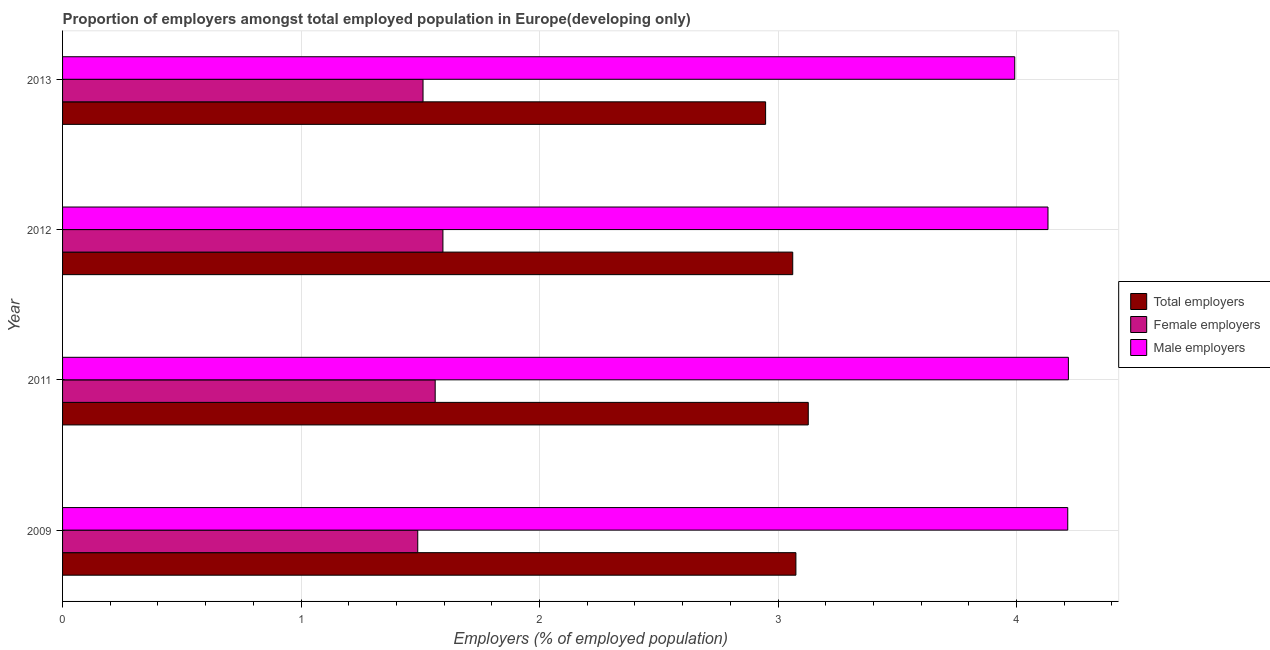How many different coloured bars are there?
Provide a succinct answer. 3. How many bars are there on the 1st tick from the bottom?
Your response must be concise. 3. What is the percentage of total employers in 2009?
Provide a succinct answer. 3.07. Across all years, what is the maximum percentage of female employers?
Offer a very short reply. 1.59. Across all years, what is the minimum percentage of female employers?
Keep it short and to the point. 1.49. In which year was the percentage of female employers minimum?
Your answer should be compact. 2009. What is the total percentage of total employers in the graph?
Make the answer very short. 12.21. What is the difference between the percentage of male employers in 2011 and that in 2012?
Provide a short and direct response. 0.09. What is the difference between the percentage of total employers in 2011 and the percentage of male employers in 2009?
Offer a very short reply. -1.09. What is the average percentage of female employers per year?
Make the answer very short. 1.54. In the year 2009, what is the difference between the percentage of total employers and percentage of male employers?
Keep it short and to the point. -1.14. What is the ratio of the percentage of male employers in 2012 to that in 2013?
Offer a very short reply. 1.03. Is the percentage of total employers in 2009 less than that in 2011?
Your answer should be very brief. Yes. What is the difference between the highest and the second highest percentage of female employers?
Provide a short and direct response. 0.03. What is the difference between the highest and the lowest percentage of female employers?
Offer a very short reply. 0.11. What does the 3rd bar from the top in 2011 represents?
Your response must be concise. Total employers. What does the 1st bar from the bottom in 2013 represents?
Make the answer very short. Total employers. Are all the bars in the graph horizontal?
Your answer should be very brief. Yes. Are the values on the major ticks of X-axis written in scientific E-notation?
Your response must be concise. No. How are the legend labels stacked?
Give a very brief answer. Vertical. What is the title of the graph?
Your answer should be compact. Proportion of employers amongst total employed population in Europe(developing only). What is the label or title of the X-axis?
Your answer should be very brief. Employers (% of employed population). What is the Employers (% of employed population) of Total employers in 2009?
Your answer should be very brief. 3.07. What is the Employers (% of employed population) in Female employers in 2009?
Give a very brief answer. 1.49. What is the Employers (% of employed population) of Male employers in 2009?
Your answer should be compact. 4.21. What is the Employers (% of employed population) in Total employers in 2011?
Provide a short and direct response. 3.13. What is the Employers (% of employed population) in Female employers in 2011?
Make the answer very short. 1.56. What is the Employers (% of employed population) in Male employers in 2011?
Offer a terse response. 4.22. What is the Employers (% of employed population) of Total employers in 2012?
Provide a succinct answer. 3.06. What is the Employers (% of employed population) of Female employers in 2012?
Ensure brevity in your answer.  1.59. What is the Employers (% of employed population) in Male employers in 2012?
Keep it short and to the point. 4.13. What is the Employers (% of employed population) of Total employers in 2013?
Your answer should be very brief. 2.95. What is the Employers (% of employed population) of Female employers in 2013?
Your answer should be compact. 1.51. What is the Employers (% of employed population) in Male employers in 2013?
Provide a succinct answer. 3.99. Across all years, what is the maximum Employers (% of employed population) of Total employers?
Give a very brief answer. 3.13. Across all years, what is the maximum Employers (% of employed population) of Female employers?
Your answer should be very brief. 1.59. Across all years, what is the maximum Employers (% of employed population) of Male employers?
Make the answer very short. 4.22. Across all years, what is the minimum Employers (% of employed population) of Total employers?
Make the answer very short. 2.95. Across all years, what is the minimum Employers (% of employed population) in Female employers?
Give a very brief answer. 1.49. Across all years, what is the minimum Employers (% of employed population) in Male employers?
Ensure brevity in your answer.  3.99. What is the total Employers (% of employed population) of Total employers in the graph?
Keep it short and to the point. 12.21. What is the total Employers (% of employed population) in Female employers in the graph?
Ensure brevity in your answer.  6.16. What is the total Employers (% of employed population) of Male employers in the graph?
Give a very brief answer. 16.56. What is the difference between the Employers (% of employed population) in Total employers in 2009 and that in 2011?
Your answer should be very brief. -0.05. What is the difference between the Employers (% of employed population) of Female employers in 2009 and that in 2011?
Keep it short and to the point. -0.07. What is the difference between the Employers (% of employed population) in Male employers in 2009 and that in 2011?
Provide a short and direct response. -0. What is the difference between the Employers (% of employed population) of Total employers in 2009 and that in 2012?
Offer a terse response. 0.01. What is the difference between the Employers (% of employed population) in Female employers in 2009 and that in 2012?
Offer a terse response. -0.11. What is the difference between the Employers (% of employed population) in Male employers in 2009 and that in 2012?
Give a very brief answer. 0.08. What is the difference between the Employers (% of employed population) in Total employers in 2009 and that in 2013?
Offer a terse response. 0.13. What is the difference between the Employers (% of employed population) in Female employers in 2009 and that in 2013?
Ensure brevity in your answer.  -0.02. What is the difference between the Employers (% of employed population) of Male employers in 2009 and that in 2013?
Your response must be concise. 0.22. What is the difference between the Employers (% of employed population) in Total employers in 2011 and that in 2012?
Offer a terse response. 0.07. What is the difference between the Employers (% of employed population) in Female employers in 2011 and that in 2012?
Your answer should be compact. -0.03. What is the difference between the Employers (% of employed population) in Male employers in 2011 and that in 2012?
Your answer should be very brief. 0.09. What is the difference between the Employers (% of employed population) of Total employers in 2011 and that in 2013?
Keep it short and to the point. 0.18. What is the difference between the Employers (% of employed population) of Female employers in 2011 and that in 2013?
Ensure brevity in your answer.  0.05. What is the difference between the Employers (% of employed population) of Male employers in 2011 and that in 2013?
Your response must be concise. 0.23. What is the difference between the Employers (% of employed population) in Total employers in 2012 and that in 2013?
Offer a very short reply. 0.11. What is the difference between the Employers (% of employed population) of Female employers in 2012 and that in 2013?
Your response must be concise. 0.08. What is the difference between the Employers (% of employed population) in Male employers in 2012 and that in 2013?
Make the answer very short. 0.14. What is the difference between the Employers (% of employed population) of Total employers in 2009 and the Employers (% of employed population) of Female employers in 2011?
Your answer should be compact. 1.51. What is the difference between the Employers (% of employed population) of Total employers in 2009 and the Employers (% of employed population) of Male employers in 2011?
Keep it short and to the point. -1.14. What is the difference between the Employers (% of employed population) of Female employers in 2009 and the Employers (% of employed population) of Male employers in 2011?
Your answer should be compact. -2.73. What is the difference between the Employers (% of employed population) in Total employers in 2009 and the Employers (% of employed population) in Female employers in 2012?
Offer a very short reply. 1.48. What is the difference between the Employers (% of employed population) of Total employers in 2009 and the Employers (% of employed population) of Male employers in 2012?
Provide a short and direct response. -1.06. What is the difference between the Employers (% of employed population) in Female employers in 2009 and the Employers (% of employed population) in Male employers in 2012?
Ensure brevity in your answer.  -2.64. What is the difference between the Employers (% of employed population) of Total employers in 2009 and the Employers (% of employed population) of Female employers in 2013?
Ensure brevity in your answer.  1.56. What is the difference between the Employers (% of employed population) in Total employers in 2009 and the Employers (% of employed population) in Male employers in 2013?
Your answer should be compact. -0.92. What is the difference between the Employers (% of employed population) of Female employers in 2009 and the Employers (% of employed population) of Male employers in 2013?
Your response must be concise. -2.5. What is the difference between the Employers (% of employed population) in Total employers in 2011 and the Employers (% of employed population) in Female employers in 2012?
Your answer should be very brief. 1.53. What is the difference between the Employers (% of employed population) in Total employers in 2011 and the Employers (% of employed population) in Male employers in 2012?
Make the answer very short. -1.01. What is the difference between the Employers (% of employed population) in Female employers in 2011 and the Employers (% of employed population) in Male employers in 2012?
Keep it short and to the point. -2.57. What is the difference between the Employers (% of employed population) of Total employers in 2011 and the Employers (% of employed population) of Female employers in 2013?
Offer a terse response. 1.62. What is the difference between the Employers (% of employed population) in Total employers in 2011 and the Employers (% of employed population) in Male employers in 2013?
Ensure brevity in your answer.  -0.87. What is the difference between the Employers (% of employed population) in Female employers in 2011 and the Employers (% of employed population) in Male employers in 2013?
Offer a very short reply. -2.43. What is the difference between the Employers (% of employed population) of Total employers in 2012 and the Employers (% of employed population) of Female employers in 2013?
Provide a succinct answer. 1.55. What is the difference between the Employers (% of employed population) in Total employers in 2012 and the Employers (% of employed population) in Male employers in 2013?
Provide a succinct answer. -0.93. What is the difference between the Employers (% of employed population) of Female employers in 2012 and the Employers (% of employed population) of Male employers in 2013?
Make the answer very short. -2.4. What is the average Employers (% of employed population) in Total employers per year?
Provide a short and direct response. 3.05. What is the average Employers (% of employed population) in Female employers per year?
Your answer should be very brief. 1.54. What is the average Employers (% of employed population) of Male employers per year?
Ensure brevity in your answer.  4.14. In the year 2009, what is the difference between the Employers (% of employed population) in Total employers and Employers (% of employed population) in Female employers?
Provide a succinct answer. 1.59. In the year 2009, what is the difference between the Employers (% of employed population) of Total employers and Employers (% of employed population) of Male employers?
Ensure brevity in your answer.  -1.14. In the year 2009, what is the difference between the Employers (% of employed population) in Female employers and Employers (% of employed population) in Male employers?
Keep it short and to the point. -2.73. In the year 2011, what is the difference between the Employers (% of employed population) of Total employers and Employers (% of employed population) of Female employers?
Keep it short and to the point. 1.56. In the year 2011, what is the difference between the Employers (% of employed population) in Total employers and Employers (% of employed population) in Male employers?
Ensure brevity in your answer.  -1.09. In the year 2011, what is the difference between the Employers (% of employed population) in Female employers and Employers (% of employed population) in Male employers?
Offer a terse response. -2.65. In the year 2012, what is the difference between the Employers (% of employed population) of Total employers and Employers (% of employed population) of Female employers?
Your response must be concise. 1.47. In the year 2012, what is the difference between the Employers (% of employed population) in Total employers and Employers (% of employed population) in Male employers?
Ensure brevity in your answer.  -1.07. In the year 2012, what is the difference between the Employers (% of employed population) of Female employers and Employers (% of employed population) of Male employers?
Ensure brevity in your answer.  -2.54. In the year 2013, what is the difference between the Employers (% of employed population) of Total employers and Employers (% of employed population) of Female employers?
Your answer should be very brief. 1.44. In the year 2013, what is the difference between the Employers (% of employed population) of Total employers and Employers (% of employed population) of Male employers?
Make the answer very short. -1.04. In the year 2013, what is the difference between the Employers (% of employed population) in Female employers and Employers (% of employed population) in Male employers?
Your answer should be compact. -2.48. What is the ratio of the Employers (% of employed population) of Total employers in 2009 to that in 2011?
Offer a terse response. 0.98. What is the ratio of the Employers (% of employed population) in Female employers in 2009 to that in 2011?
Your answer should be very brief. 0.95. What is the ratio of the Employers (% of employed population) in Total employers in 2009 to that in 2012?
Your answer should be compact. 1. What is the ratio of the Employers (% of employed population) of Female employers in 2009 to that in 2012?
Your response must be concise. 0.93. What is the ratio of the Employers (% of employed population) in Male employers in 2009 to that in 2012?
Provide a short and direct response. 1.02. What is the ratio of the Employers (% of employed population) in Total employers in 2009 to that in 2013?
Give a very brief answer. 1.04. What is the ratio of the Employers (% of employed population) of Female employers in 2009 to that in 2013?
Make the answer very short. 0.99. What is the ratio of the Employers (% of employed population) of Male employers in 2009 to that in 2013?
Offer a terse response. 1.06. What is the ratio of the Employers (% of employed population) of Total employers in 2011 to that in 2012?
Your answer should be very brief. 1.02. What is the ratio of the Employers (% of employed population) of Female employers in 2011 to that in 2012?
Provide a succinct answer. 0.98. What is the ratio of the Employers (% of employed population) in Male employers in 2011 to that in 2012?
Keep it short and to the point. 1.02. What is the ratio of the Employers (% of employed population) in Total employers in 2011 to that in 2013?
Provide a short and direct response. 1.06. What is the ratio of the Employers (% of employed population) in Female employers in 2011 to that in 2013?
Offer a very short reply. 1.03. What is the ratio of the Employers (% of employed population) of Male employers in 2011 to that in 2013?
Make the answer very short. 1.06. What is the ratio of the Employers (% of employed population) of Total employers in 2012 to that in 2013?
Provide a succinct answer. 1.04. What is the ratio of the Employers (% of employed population) in Female employers in 2012 to that in 2013?
Offer a terse response. 1.06. What is the ratio of the Employers (% of employed population) in Male employers in 2012 to that in 2013?
Your response must be concise. 1.03. What is the difference between the highest and the second highest Employers (% of employed population) of Total employers?
Offer a very short reply. 0.05. What is the difference between the highest and the second highest Employers (% of employed population) in Female employers?
Keep it short and to the point. 0.03. What is the difference between the highest and the second highest Employers (% of employed population) of Male employers?
Keep it short and to the point. 0. What is the difference between the highest and the lowest Employers (% of employed population) of Total employers?
Make the answer very short. 0.18. What is the difference between the highest and the lowest Employers (% of employed population) of Female employers?
Your answer should be compact. 0.11. What is the difference between the highest and the lowest Employers (% of employed population) in Male employers?
Give a very brief answer. 0.23. 